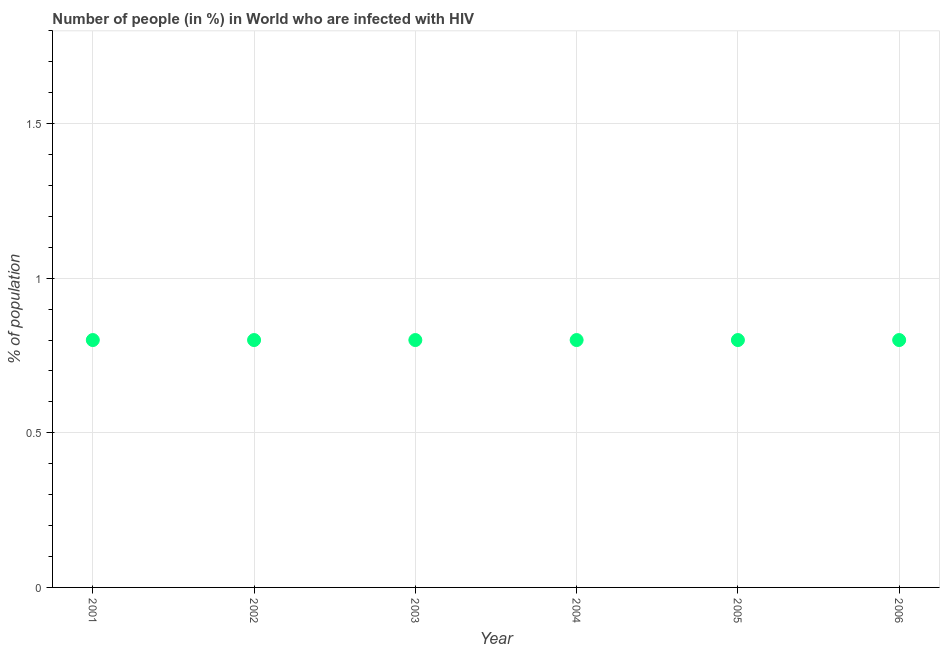What is the number of people infected with hiv in 2005?
Offer a terse response. 0.8. Across all years, what is the maximum number of people infected with hiv?
Offer a very short reply. 0.8. What is the average number of people infected with hiv per year?
Give a very brief answer. 0.8. What is the ratio of the number of people infected with hiv in 2001 to that in 2006?
Keep it short and to the point. 1. Is the difference between the number of people infected with hiv in 2005 and 2006 greater than the difference between any two years?
Your response must be concise. Yes. What is the difference between the highest and the second highest number of people infected with hiv?
Keep it short and to the point. 0. Is the sum of the number of people infected with hiv in 2004 and 2006 greater than the maximum number of people infected with hiv across all years?
Provide a short and direct response. Yes. What is the difference between the highest and the lowest number of people infected with hiv?
Give a very brief answer. 0. In how many years, is the number of people infected with hiv greater than the average number of people infected with hiv taken over all years?
Your answer should be very brief. 6. Does the number of people infected with hiv monotonically increase over the years?
Your answer should be very brief. No. How many dotlines are there?
Your answer should be compact. 1. Are the values on the major ticks of Y-axis written in scientific E-notation?
Ensure brevity in your answer.  No. Does the graph contain any zero values?
Your response must be concise. No. Does the graph contain grids?
Provide a succinct answer. Yes. What is the title of the graph?
Make the answer very short. Number of people (in %) in World who are infected with HIV. What is the label or title of the Y-axis?
Ensure brevity in your answer.  % of population. What is the % of population in 2002?
Keep it short and to the point. 0.8. What is the % of population in 2005?
Offer a very short reply. 0.8. What is the % of population in 2006?
Provide a succinct answer. 0.8. What is the difference between the % of population in 2001 and 2006?
Provide a short and direct response. 0. What is the difference between the % of population in 2002 and 2005?
Your answer should be compact. 0. What is the difference between the % of population in 2003 and 2004?
Give a very brief answer. 0. What is the difference between the % of population in 2005 and 2006?
Make the answer very short. 0. What is the ratio of the % of population in 2001 to that in 2003?
Provide a succinct answer. 1. What is the ratio of the % of population in 2001 to that in 2004?
Give a very brief answer. 1. What is the ratio of the % of population in 2001 to that in 2005?
Your answer should be compact. 1. What is the ratio of the % of population in 2001 to that in 2006?
Ensure brevity in your answer.  1. What is the ratio of the % of population in 2002 to that in 2004?
Ensure brevity in your answer.  1. What is the ratio of the % of population in 2003 to that in 2004?
Keep it short and to the point. 1. What is the ratio of the % of population in 2003 to that in 2005?
Offer a terse response. 1. What is the ratio of the % of population in 2004 to that in 2006?
Give a very brief answer. 1. What is the ratio of the % of population in 2005 to that in 2006?
Make the answer very short. 1. 